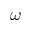Convert formula to latex. <formula><loc_0><loc_0><loc_500><loc_500>\omega</formula> 